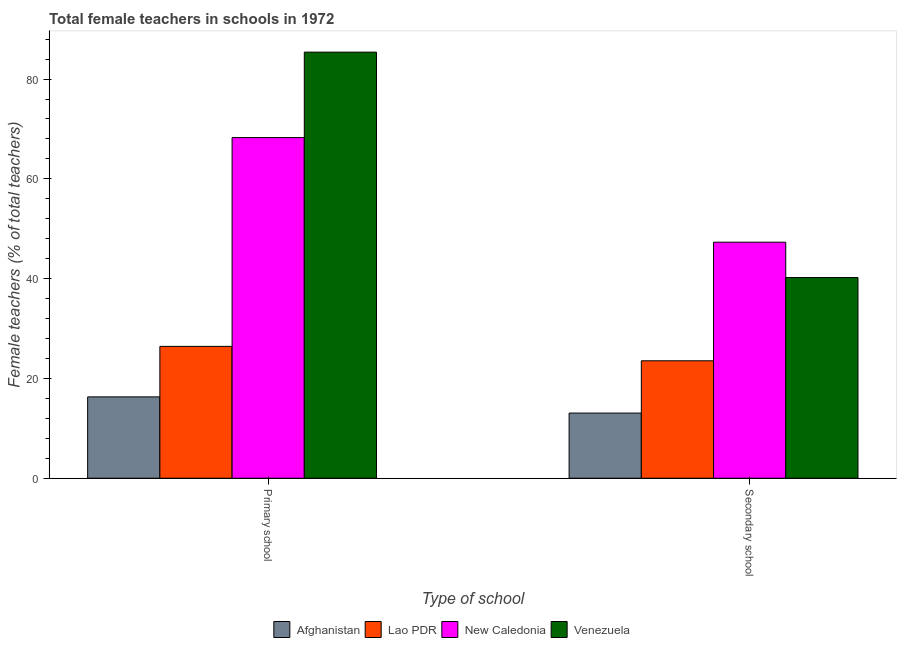How many different coloured bars are there?
Ensure brevity in your answer.  4. Are the number of bars on each tick of the X-axis equal?
Ensure brevity in your answer.  Yes. What is the label of the 2nd group of bars from the left?
Make the answer very short. Secondary school. What is the percentage of female teachers in primary schools in Afghanistan?
Offer a terse response. 16.3. Across all countries, what is the maximum percentage of female teachers in primary schools?
Make the answer very short. 85.4. Across all countries, what is the minimum percentage of female teachers in secondary schools?
Your answer should be compact. 13.06. In which country was the percentage of female teachers in secondary schools maximum?
Give a very brief answer. New Caledonia. In which country was the percentage of female teachers in primary schools minimum?
Give a very brief answer. Afghanistan. What is the total percentage of female teachers in secondary schools in the graph?
Your answer should be very brief. 124.12. What is the difference between the percentage of female teachers in primary schools in New Caledonia and that in Lao PDR?
Offer a very short reply. 41.84. What is the difference between the percentage of female teachers in secondary schools in New Caledonia and the percentage of female teachers in primary schools in Afghanistan?
Offer a terse response. 31. What is the average percentage of female teachers in primary schools per country?
Provide a succinct answer. 49.1. What is the difference between the percentage of female teachers in secondary schools and percentage of female teachers in primary schools in Lao PDR?
Keep it short and to the point. -2.89. In how many countries, is the percentage of female teachers in primary schools greater than 52 %?
Provide a succinct answer. 2. What is the ratio of the percentage of female teachers in secondary schools in Lao PDR to that in New Caledonia?
Ensure brevity in your answer.  0.5. Is the percentage of female teachers in secondary schools in Afghanistan less than that in Lao PDR?
Provide a short and direct response. Yes. What does the 1st bar from the left in Secondary school represents?
Keep it short and to the point. Afghanistan. What does the 3rd bar from the right in Primary school represents?
Provide a short and direct response. Lao PDR. Are all the bars in the graph horizontal?
Your answer should be very brief. No. How many countries are there in the graph?
Your response must be concise. 4. Does the graph contain any zero values?
Ensure brevity in your answer.  No. Where does the legend appear in the graph?
Offer a very short reply. Bottom center. How many legend labels are there?
Your response must be concise. 4. What is the title of the graph?
Offer a terse response. Total female teachers in schools in 1972. Does "St. Kitts and Nevis" appear as one of the legend labels in the graph?
Provide a succinct answer. No. What is the label or title of the X-axis?
Offer a very short reply. Type of school. What is the label or title of the Y-axis?
Offer a terse response. Female teachers (% of total teachers). What is the Female teachers (% of total teachers) of Afghanistan in Primary school?
Keep it short and to the point. 16.3. What is the Female teachers (% of total teachers) of Lao PDR in Primary school?
Offer a very short reply. 26.43. What is the Female teachers (% of total teachers) in New Caledonia in Primary school?
Make the answer very short. 68.27. What is the Female teachers (% of total teachers) of Venezuela in Primary school?
Provide a succinct answer. 85.4. What is the Female teachers (% of total teachers) of Afghanistan in Secondary school?
Provide a succinct answer. 13.06. What is the Female teachers (% of total teachers) of Lao PDR in Secondary school?
Provide a succinct answer. 23.54. What is the Female teachers (% of total teachers) in New Caledonia in Secondary school?
Your answer should be compact. 47.3. What is the Female teachers (% of total teachers) in Venezuela in Secondary school?
Make the answer very short. 40.22. Across all Type of school, what is the maximum Female teachers (% of total teachers) in Afghanistan?
Your answer should be very brief. 16.3. Across all Type of school, what is the maximum Female teachers (% of total teachers) in Lao PDR?
Provide a short and direct response. 26.43. Across all Type of school, what is the maximum Female teachers (% of total teachers) in New Caledonia?
Provide a short and direct response. 68.27. Across all Type of school, what is the maximum Female teachers (% of total teachers) of Venezuela?
Your answer should be very brief. 85.4. Across all Type of school, what is the minimum Female teachers (% of total teachers) in Afghanistan?
Provide a short and direct response. 13.06. Across all Type of school, what is the minimum Female teachers (% of total teachers) of Lao PDR?
Ensure brevity in your answer.  23.54. Across all Type of school, what is the minimum Female teachers (% of total teachers) of New Caledonia?
Your answer should be very brief. 47.3. Across all Type of school, what is the minimum Female teachers (% of total teachers) in Venezuela?
Give a very brief answer. 40.22. What is the total Female teachers (% of total teachers) of Afghanistan in the graph?
Provide a short and direct response. 29.36. What is the total Female teachers (% of total teachers) of Lao PDR in the graph?
Give a very brief answer. 49.96. What is the total Female teachers (% of total teachers) in New Caledonia in the graph?
Your response must be concise. 115.57. What is the total Female teachers (% of total teachers) in Venezuela in the graph?
Offer a very short reply. 125.62. What is the difference between the Female teachers (% of total teachers) in Afghanistan in Primary school and that in Secondary school?
Your answer should be very brief. 3.24. What is the difference between the Female teachers (% of total teachers) in Lao PDR in Primary school and that in Secondary school?
Offer a very short reply. 2.89. What is the difference between the Female teachers (% of total teachers) of New Caledonia in Primary school and that in Secondary school?
Offer a very short reply. 20.97. What is the difference between the Female teachers (% of total teachers) in Venezuela in Primary school and that in Secondary school?
Your response must be concise. 45.17. What is the difference between the Female teachers (% of total teachers) in Afghanistan in Primary school and the Female teachers (% of total teachers) in Lao PDR in Secondary school?
Provide a succinct answer. -7.23. What is the difference between the Female teachers (% of total teachers) of Afghanistan in Primary school and the Female teachers (% of total teachers) of New Caledonia in Secondary school?
Give a very brief answer. -31. What is the difference between the Female teachers (% of total teachers) in Afghanistan in Primary school and the Female teachers (% of total teachers) in Venezuela in Secondary school?
Provide a short and direct response. -23.92. What is the difference between the Female teachers (% of total teachers) in Lao PDR in Primary school and the Female teachers (% of total teachers) in New Caledonia in Secondary school?
Provide a succinct answer. -20.87. What is the difference between the Female teachers (% of total teachers) of Lao PDR in Primary school and the Female teachers (% of total teachers) of Venezuela in Secondary school?
Make the answer very short. -13.79. What is the difference between the Female teachers (% of total teachers) of New Caledonia in Primary school and the Female teachers (% of total teachers) of Venezuela in Secondary school?
Ensure brevity in your answer.  28.05. What is the average Female teachers (% of total teachers) in Afghanistan per Type of school?
Offer a terse response. 14.68. What is the average Female teachers (% of total teachers) in Lao PDR per Type of school?
Your response must be concise. 24.98. What is the average Female teachers (% of total teachers) in New Caledonia per Type of school?
Offer a terse response. 57.79. What is the average Female teachers (% of total teachers) in Venezuela per Type of school?
Offer a terse response. 62.81. What is the difference between the Female teachers (% of total teachers) in Afghanistan and Female teachers (% of total teachers) in Lao PDR in Primary school?
Provide a succinct answer. -10.13. What is the difference between the Female teachers (% of total teachers) of Afghanistan and Female teachers (% of total teachers) of New Caledonia in Primary school?
Your response must be concise. -51.97. What is the difference between the Female teachers (% of total teachers) of Afghanistan and Female teachers (% of total teachers) of Venezuela in Primary school?
Provide a short and direct response. -69.09. What is the difference between the Female teachers (% of total teachers) of Lao PDR and Female teachers (% of total teachers) of New Caledonia in Primary school?
Your response must be concise. -41.84. What is the difference between the Female teachers (% of total teachers) in Lao PDR and Female teachers (% of total teachers) in Venezuela in Primary school?
Your answer should be compact. -58.97. What is the difference between the Female teachers (% of total teachers) of New Caledonia and Female teachers (% of total teachers) of Venezuela in Primary school?
Ensure brevity in your answer.  -17.13. What is the difference between the Female teachers (% of total teachers) in Afghanistan and Female teachers (% of total teachers) in Lao PDR in Secondary school?
Make the answer very short. -10.48. What is the difference between the Female teachers (% of total teachers) of Afghanistan and Female teachers (% of total teachers) of New Caledonia in Secondary school?
Keep it short and to the point. -34.24. What is the difference between the Female teachers (% of total teachers) of Afghanistan and Female teachers (% of total teachers) of Venezuela in Secondary school?
Ensure brevity in your answer.  -27.16. What is the difference between the Female teachers (% of total teachers) of Lao PDR and Female teachers (% of total teachers) of New Caledonia in Secondary school?
Provide a succinct answer. -23.77. What is the difference between the Female teachers (% of total teachers) of Lao PDR and Female teachers (% of total teachers) of Venezuela in Secondary school?
Your response must be concise. -16.69. What is the difference between the Female teachers (% of total teachers) of New Caledonia and Female teachers (% of total teachers) of Venezuela in Secondary school?
Your response must be concise. 7.08. What is the ratio of the Female teachers (% of total teachers) in Afghanistan in Primary school to that in Secondary school?
Offer a very short reply. 1.25. What is the ratio of the Female teachers (% of total teachers) of Lao PDR in Primary school to that in Secondary school?
Your answer should be very brief. 1.12. What is the ratio of the Female teachers (% of total teachers) in New Caledonia in Primary school to that in Secondary school?
Provide a short and direct response. 1.44. What is the ratio of the Female teachers (% of total teachers) in Venezuela in Primary school to that in Secondary school?
Your response must be concise. 2.12. What is the difference between the highest and the second highest Female teachers (% of total teachers) of Afghanistan?
Make the answer very short. 3.24. What is the difference between the highest and the second highest Female teachers (% of total teachers) of Lao PDR?
Offer a very short reply. 2.89. What is the difference between the highest and the second highest Female teachers (% of total teachers) in New Caledonia?
Provide a succinct answer. 20.97. What is the difference between the highest and the second highest Female teachers (% of total teachers) of Venezuela?
Keep it short and to the point. 45.17. What is the difference between the highest and the lowest Female teachers (% of total teachers) of Afghanistan?
Provide a succinct answer. 3.24. What is the difference between the highest and the lowest Female teachers (% of total teachers) in Lao PDR?
Provide a short and direct response. 2.89. What is the difference between the highest and the lowest Female teachers (% of total teachers) in New Caledonia?
Your answer should be compact. 20.97. What is the difference between the highest and the lowest Female teachers (% of total teachers) in Venezuela?
Make the answer very short. 45.17. 